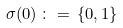Convert formula to latex. <formula><loc_0><loc_0><loc_500><loc_500>\sigma ( 0 ) \, \colon = \, \{ 0 , 1 \}</formula> 